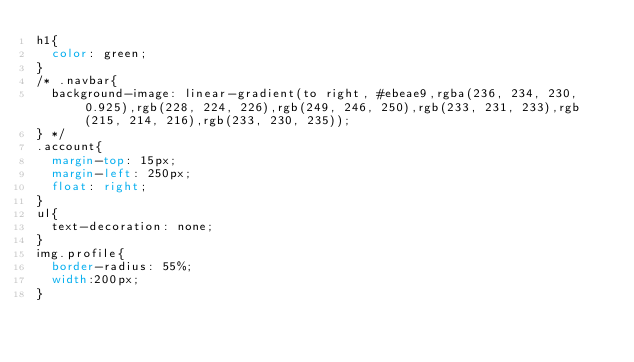<code> <loc_0><loc_0><loc_500><loc_500><_CSS_>h1{
  color: green;
}
/* .navbar{
  background-image: linear-gradient(to right, #ebeae9,rgba(236, 234, 230, 0.925),rgb(228, 224, 226),rgb(249, 246, 250),rgb(233, 231, 233),rgb(215, 214, 216),rgb(233, 230, 235));
} */
.account{
  margin-top: 15px;
  margin-left: 250px;
  float: right;
}
ul{
  text-decoration: none;
}
img.profile{
  border-radius: 55%;
  width:200px;
}
</code> 